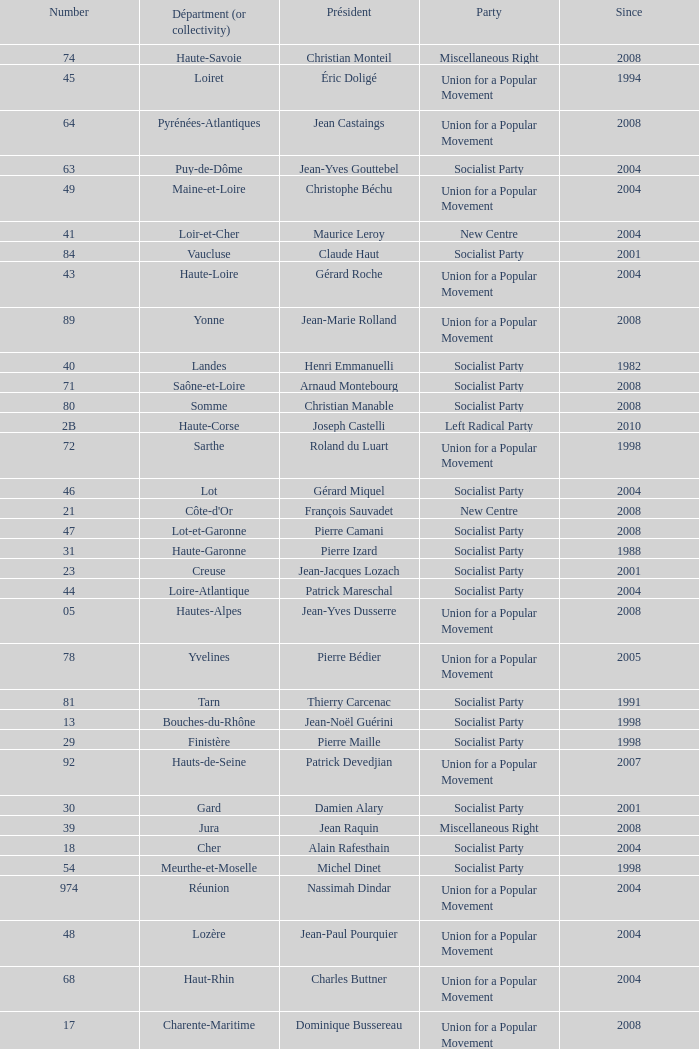What number corresponds to Presidet Yves Krattinger of the Socialist party? 70.0. Give me the full table as a dictionary. {'header': ['Number', 'Départment (or collectivity)', 'Président', 'Party', 'Since'], 'rows': [['74', 'Haute-Savoie', 'Christian Monteil', 'Miscellaneous Right', '2008'], ['45', 'Loiret', 'Éric Doligé', 'Union for a Popular Movement', '1994'], ['64', 'Pyrénées-Atlantiques', 'Jean Castaings', 'Union for a Popular Movement', '2008'], ['63', 'Puy-de-Dôme', 'Jean-Yves Gouttebel', 'Socialist Party', '2004'], ['49', 'Maine-et-Loire', 'Christophe Béchu', 'Union for a Popular Movement', '2004'], ['41', 'Loir-et-Cher', 'Maurice Leroy', 'New Centre', '2004'], ['84', 'Vaucluse', 'Claude Haut', 'Socialist Party', '2001'], ['43', 'Haute-Loire', 'Gérard Roche', 'Union for a Popular Movement', '2004'], ['89', 'Yonne', 'Jean-Marie Rolland', 'Union for a Popular Movement', '2008'], ['40', 'Landes', 'Henri Emmanuelli', 'Socialist Party', '1982'], ['71', 'Saône-et-Loire', 'Arnaud Montebourg', 'Socialist Party', '2008'], ['80', 'Somme', 'Christian Manable', 'Socialist Party', '2008'], ['2B', 'Haute-Corse', 'Joseph Castelli', 'Left Radical Party', '2010'], ['72', 'Sarthe', 'Roland du Luart', 'Union for a Popular Movement', '1998'], ['46', 'Lot', 'Gérard Miquel', 'Socialist Party', '2004'], ['21', "Côte-d'Or", 'François Sauvadet', 'New Centre', '2008'], ['47', 'Lot-et-Garonne', 'Pierre Camani', 'Socialist Party', '2008'], ['31', 'Haute-Garonne', 'Pierre Izard', 'Socialist Party', '1988'], ['23', 'Creuse', 'Jean-Jacques Lozach', 'Socialist Party', '2001'], ['44', 'Loire-Atlantique', 'Patrick Mareschal', 'Socialist Party', '2004'], ['05', 'Hautes-Alpes', 'Jean-Yves Dusserre', 'Union for a Popular Movement', '2008'], ['78', 'Yvelines', 'Pierre Bédier', 'Union for a Popular Movement', '2005'], ['81', 'Tarn', 'Thierry Carcenac', 'Socialist Party', '1991'], ['13', 'Bouches-du-Rhône', 'Jean-Noël Guérini', 'Socialist Party', '1998'], ['29', 'Finistère', 'Pierre Maille', 'Socialist Party', '1998'], ['92', 'Hauts-de-Seine', 'Patrick Devedjian', 'Union for a Popular Movement', '2007'], ['30', 'Gard', 'Damien Alary', 'Socialist Party', '2001'], ['39', 'Jura', 'Jean Raquin', 'Miscellaneous Right', '2008'], ['18', 'Cher', 'Alain Rafesthain', 'Socialist Party', '2004'], ['54', 'Meurthe-et-Moselle', 'Michel Dinet', 'Socialist Party', '1998'], ['974', 'Réunion', 'Nassimah Dindar', 'Union for a Popular Movement', '2004'], ['48', 'Lozère', 'Jean-Paul Pourquier', 'Union for a Popular Movement', '2004'], ['68', 'Haut-Rhin', 'Charles Buttner', 'Union for a Popular Movement', '2004'], ['17', 'Charente-Maritime', 'Dominique Bussereau', 'Union for a Popular Movement', '2008'], ['38', 'Isère', 'André Vallini', 'Socialist Party', '2001'], ['975', 'Saint-Pierre-et-Miquelon (overseas collect.)', 'Stéphane Artano', 'Archipelago Tomorrow', '2006'], ['88', 'Vosges', 'Christian Poncelet', 'Union for a Popular Movement', '1976'], ['91', 'Essonne', 'Michel Berson', 'Socialist Party', '1998'], ['77', 'Seine-et-Marne', 'Vincent Eblé', 'Socialist Party', '2004'], ['24', 'Dordogne', 'Bernard Cazeau', 'Socialist Party', '1994'], ['36', 'Indre', 'Louis Pinton', 'Union for a Popular Movement', '1998'], ['06', 'Alpes-Maritimes', 'Éric Ciotti', 'Union for a Popular Movement', '2008'], ['61', 'Orne', 'Alain Lambert', 'Union for a Popular Movement', '2007'], ['37', 'Indre-et-Loire', 'Claude Roiron', 'Socialist Party', '2008'], ['56', 'Morbihan', 'Joseph-François Kerguéris', 'Democratic Movement', '2004'], ['976', 'Mayotte (overseas collect.)', 'Ahmed Attoumani Douchina', 'Union for a Popular Movement', '2008'], ['82', 'Tarn-et-Garonne', 'Jean-Michel Baylet', 'Left Radical Party', '1986'], ['26', 'Drôme', 'Didier Guillaume', 'Socialist Party', '2004'], ['55', 'Meuse', 'Christian Namy', 'Miscellaneous Right', '2004'], ['65', 'Hautes-Pyrénées', 'Josette Durrieu', 'Socialist Party', '2008'], ['03', 'Allier', 'Jean-Paul Dufregne', 'French Communist Party', '2008'], ['73', 'Savoie', 'Hervé Gaymard', 'Union for a Popular Movement', '2008'], ['75', 'Paris', 'Bertrand Delanoë', 'Socialist Party', '2001'], ['04', 'Alpes-de-Haute-Provence', 'Jean-Louis Bianco', 'Socialist Party', '1998'], ['22', "Côtes-d'Armor", 'Claudy Lebreton', 'Socialist Party', '1997'], ['67', 'Bas-Rhin', 'Guy-Dominique Kennel', 'Union for a Popular Movement', '2008'], ['09', 'Ariège', 'Augustin Bonrepaux', 'Socialist Party', '2001'], ['93', 'Seine-Saint-Denis', 'Claude Bartolone', 'Socialist Party', '2008'], ['10', 'Aube', 'Philippe Adnot', 'Liberal and Moderate Movement', '1990'], ['25', 'Doubs', 'Claude Jeannerot', 'Socialist Party', '2004'], ['34', 'Hérault', 'André Vezinhet', 'Socialist Party', '1998'], ['90', 'Territoire de Belfort', 'Yves Ackermann', 'Socialist Party', '2004'], ['52', 'Haute-Marne', 'Bruno Sido', 'Union for a Popular Movement', '1998'], ['94', 'Val-de-Marne', 'Christian Favier', 'French Communist Party', '2001'], ['27', 'Eure', 'Jean-Louis Destans', 'Socialist Party', '2001'], ['33', 'Gironde', 'Philippe Madrelle', 'Socialist Party', '1988'], ['70', 'Haute-Saône', 'Yves Krattinger', 'Socialist Party', '2002'], ['42', 'Loire', 'Bernard Bonne', 'Union for a Popular Movement', '2008'], ['07', 'Ardèche', 'Pascal Terrasse', 'Socialist Party', '2006'], ['32', 'Gers', 'Philippe Martin', 'Socialist Party', '1998'], ['60', 'Oise', 'Yves Rome', 'Socialist Party', '2004'], ['15', 'Cantal', 'Vincent Descœur', 'Union for a Popular Movement', '2001'], ['87', 'Haute-Vienne', 'Marie-Françoise Pérol-Dumont', 'Socialist Party', '2004'], ['59', 'Nord', 'Patrick Kanner', 'Socialist Party', '1998'], ['79', 'Deux-Sèvres', 'Éric Gautier', 'Socialist Party', '2008'], ['69', 'Rhône', 'Michel Mercier', 'Miscellaneous Centre', '1990'], ['19', 'Corrèze', 'François Hollande', 'Socialist Party', '2008'], ['35', 'Ille-et-Vilaine', 'Jean-Louis Tourenne', 'Socialist Party', '2004'], ['14', 'Calvados', "Anne d'Ornano", 'Miscellaneous Right', '1991'], ['86', 'Vienne', 'Claude Bertaud', 'Union for a Popular Movement', '2008'], ['95', 'Val-d’Oise', 'Arnaud Bazin', 'Union for a Popular Movement', '2011'], ['53', 'Mayenne', 'Jean Arthuis', 'Miscellaneous Centre', '1992'], ['57', 'Moselle', 'Philippe Leroy', 'Union for a Popular Movement', '1992'], ['76', 'Seine-Maritime', 'Didier Marie', 'Socialist Party', '2004'], ['971', 'Guadeloupe', 'Jacques Gillot', 'United Guadeloupe, Socialism and Realities', '2001'], ['12', 'Aveyron', 'Jean-Claude Luche', 'Union for a Popular Movement', '2008'], ['66', 'Pyrénées-Orientales', 'Christian Bourquin', 'Socialist Party', '1998'], ['01', 'Ain', 'Rachel Mazuir', 'Socialist Party', '2008'], ['51', 'Marne', 'René-Paul Savary', 'Union for a Popular Movement', '2003'], ['85', 'Vendée', 'Philippe de Villiers', 'Movement for France', '1988'], ['50', 'Manche', 'Jean-François Le Grand', 'Union for a Popular Movement', '1998'], ['28', 'Eure-et-Loir', 'Albéric de Montgolfier', 'Union for a Popular Movement', '2001'], ['11', 'Aude', 'Marcel Rainaud', 'Socialist Party', '1998'], ['973', 'Guyane', 'Alain Tien-Liong', 'Miscellaneous Left', '2008'], ['16', 'Charente', 'Michel Boutant', 'Socialist Party', '2004'], ['83', 'Var', 'Horace Lanfranchi', 'Union for a Popular Movement', '2002'], ['62', 'Pas-de-Calais', 'Dominique Dupilet', 'Socialist Party', '2004'], ['972', 'Martinique', 'Claude Lise', 'Martinican Democratic Rally', '1992'], ['58', 'Nièvre', 'Marcel Charmant', 'Socialist Party', '2001'], ['08', 'Ardennes', 'Benoît Huré', 'Union for a Popular Movement', '2004'], ['02', 'Aisne', 'Yves Daudigny', 'Socialist Party', '2001'], ['2A', 'Corse-du-Sud', 'Jean-Jacques Panunzi', 'Union for a Popular Movement', '2006']]} 